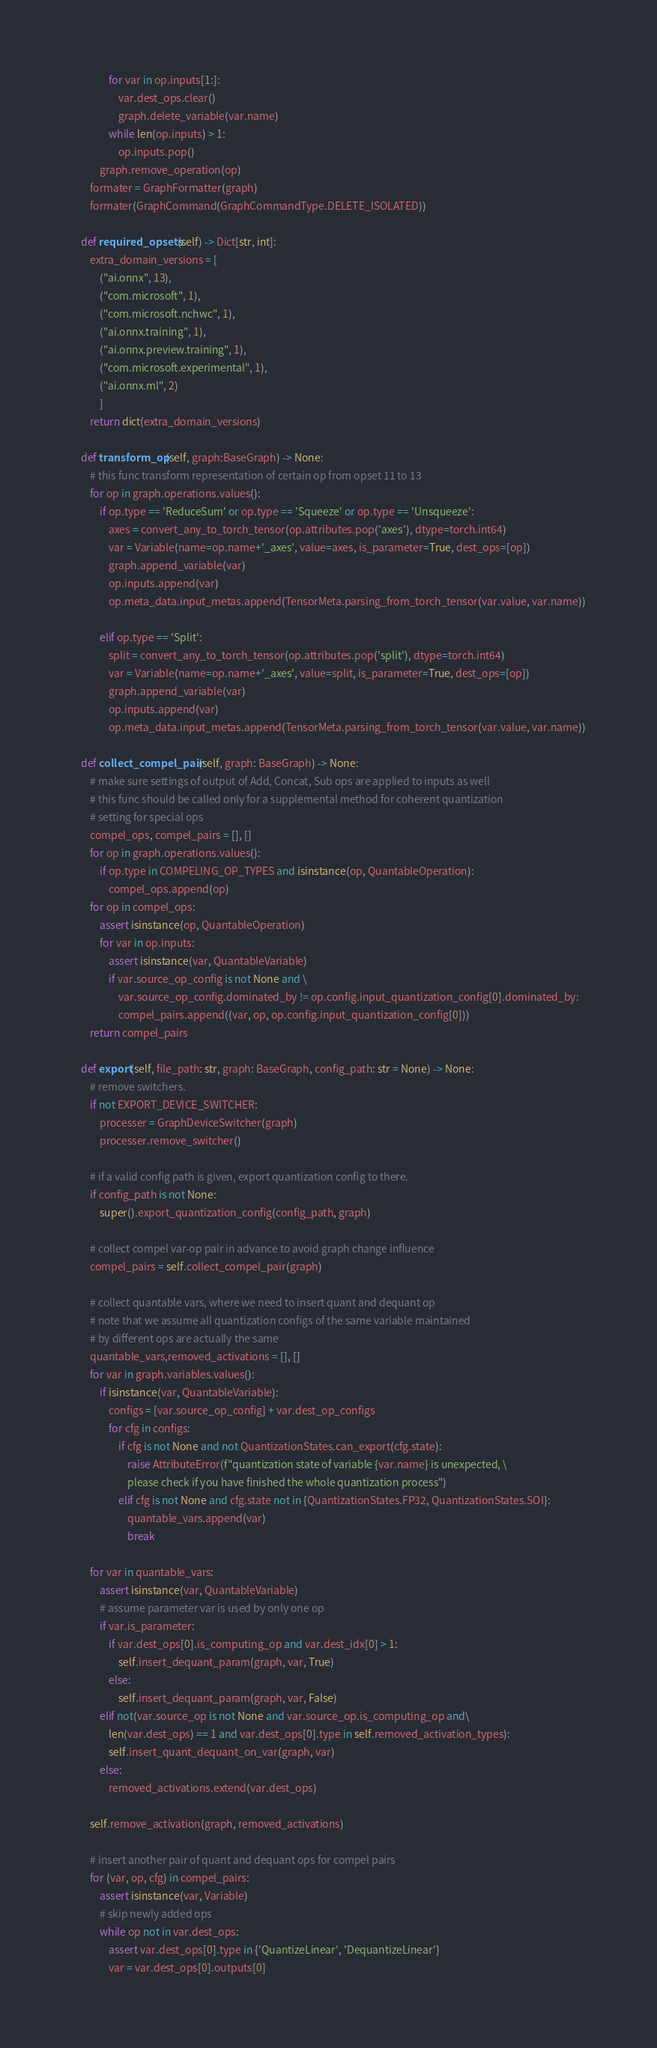<code> <loc_0><loc_0><loc_500><loc_500><_Python_>                for var in op.inputs[1:]:
                    var.dest_ops.clear()
                    graph.delete_variable(var.name)
                while len(op.inputs) > 1:
                    op.inputs.pop()
            graph.remove_operation(op)
        formater = GraphFormatter(graph)
        formater(GraphCommand(GraphCommandType.DELETE_ISOLATED))

    def required_opsets(self) -> Dict[str, int]:
        extra_domain_versions = [
            ("ai.onnx", 13),
            ("com.microsoft", 1),
            ("com.microsoft.nchwc", 1),
            ("ai.onnx.training", 1),
            ("ai.onnx.preview.training", 1),
            ("com.microsoft.experimental", 1),
            ("ai.onnx.ml", 2)
            ]
        return dict(extra_domain_versions)

    def transform_op(self, graph:BaseGraph) -> None:
        # this func transform representation of certain op from opset 11 to 13
        for op in graph.operations.values():
            if op.type == 'ReduceSum' or op.type == 'Squeeze' or op.type == 'Unsqueeze':
                axes = convert_any_to_torch_tensor(op.attributes.pop('axes'), dtype=torch.int64)
                var = Variable(name=op.name+'_axes', value=axes, is_parameter=True, dest_ops=[op])
                graph.append_variable(var)
                op.inputs.append(var)
                op.meta_data.input_metas.append(TensorMeta.parsing_from_torch_tensor(var.value, var.name))

            elif op.type == 'Split':
                split = convert_any_to_torch_tensor(op.attributes.pop('split'), dtype=torch.int64)
                var = Variable(name=op.name+'_axes', value=split, is_parameter=True, dest_ops=[op])
                graph.append_variable(var)
                op.inputs.append(var)
                op.meta_data.input_metas.append(TensorMeta.parsing_from_torch_tensor(var.value, var.name))

    def collect_compel_pair(self, graph: BaseGraph) -> None:
        # make sure settings of output of Add, Concat, Sub ops are applied to inputs as well
        # this func should be called only for a supplemental method for coherent quantization
        # setting for special ops
        compel_ops, compel_pairs = [], []
        for op in graph.operations.values():
            if op.type in COMPELING_OP_TYPES and isinstance(op, QuantableOperation):
                compel_ops.append(op)
        for op in compel_ops:
            assert isinstance(op, QuantableOperation)
            for var in op.inputs:
                assert isinstance(var, QuantableVariable)
                if var.source_op_config is not None and \
                    var.source_op_config.dominated_by != op.config.input_quantization_config[0].dominated_by:
                    compel_pairs.append((var, op, op.config.input_quantization_config[0]))
        return compel_pairs

    def export(self, file_path: str, graph: BaseGraph, config_path: str = None) -> None:
        # remove switchers.
        if not EXPORT_DEVICE_SWITCHER:
            processer = GraphDeviceSwitcher(graph)
            processer.remove_switcher()

        # if a valid config path is given, export quantization config to there.
        if config_path is not None:
            super().export_quantization_config(config_path, graph)

        # collect compel var-op pair in advance to avoid graph change influence
        compel_pairs = self.collect_compel_pair(graph)

        # collect quantable vars, where we need to insert quant and dequant op
        # note that we assume all quantization configs of the same variable maintained 
        # by different ops are actually the same
        quantable_vars,removed_activations = [], []
        for var in graph.variables.values():
            if isinstance(var, QuantableVariable):
                configs = [var.source_op_config] + var.dest_op_configs
                for cfg in configs:
                    if cfg is not None and not QuantizationStates.can_export(cfg.state):
                        raise AttributeError(f"quantization state of variable {var.name} is unexpected, \
                        please check if you have finished the whole quantization process")
                    elif cfg is not None and cfg.state not in {QuantizationStates.FP32, QuantizationStates.SOI}:
                        quantable_vars.append(var)
                        break

        for var in quantable_vars:
            assert isinstance(var, QuantableVariable)
            # assume parameter var is used by only one op
            if var.is_parameter:
                if var.dest_ops[0].is_computing_op and var.dest_idx[0] > 1:
                    self.insert_dequant_param(graph, var, True)
                else:
                    self.insert_dequant_param(graph, var, False)
            elif not(var.source_op is not None and var.source_op.is_computing_op and\
                len(var.dest_ops) == 1 and var.dest_ops[0].type in self.removed_activation_types):
                self.insert_quant_dequant_on_var(graph, var)
            else:
                removed_activations.extend(var.dest_ops)

        self.remove_activation(graph, removed_activations)

        # insert another pair of quant and dequant ops for compel pairs
        for (var, op, cfg) in compel_pairs:
            assert isinstance(var, Variable)
            # skip newly added ops
            while op not in var.dest_ops:
                assert var.dest_ops[0].type in {'QuantizeLinear', 'DequantizeLinear'}
                var = var.dest_ops[0].outputs[0]</code> 